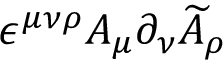<formula> <loc_0><loc_0><loc_500><loc_500>\epsilon ^ { \mu \nu \rho } A _ { \mu } \partial _ { \nu } \widetilde { A } _ { \rho }</formula> 